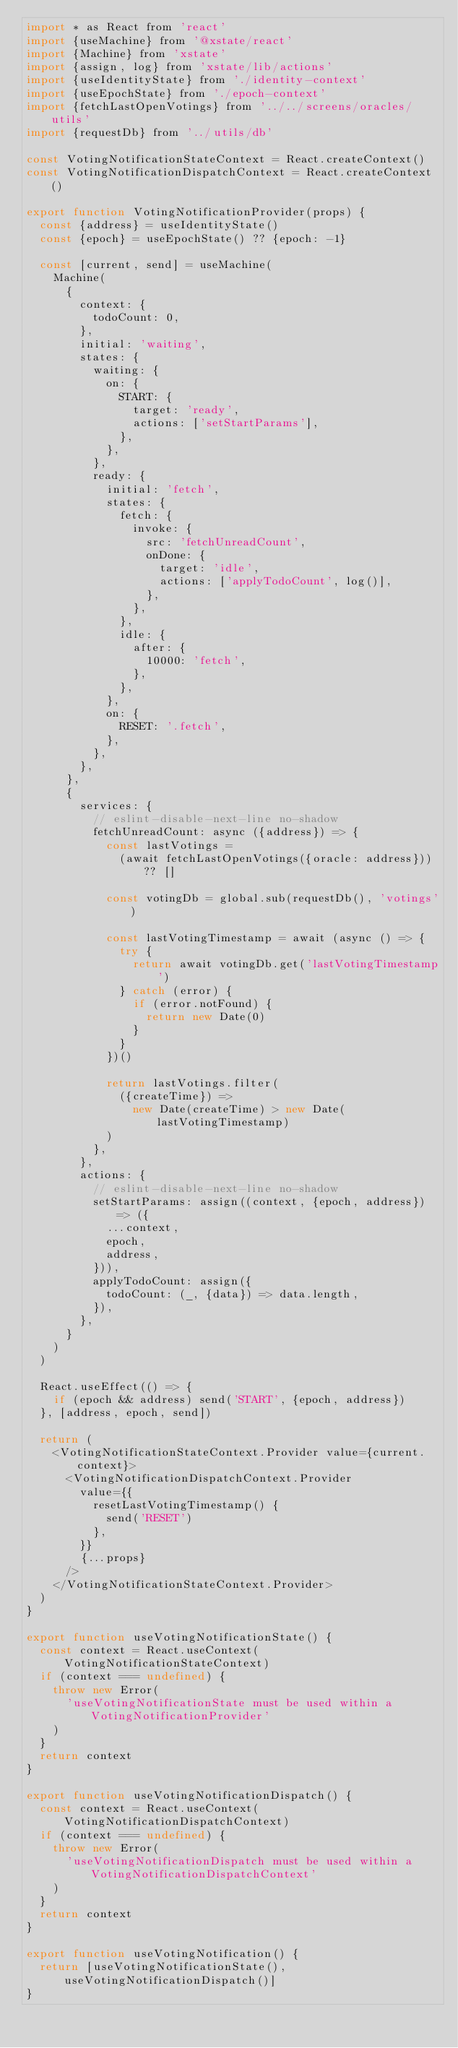<code> <loc_0><loc_0><loc_500><loc_500><_JavaScript_>import * as React from 'react'
import {useMachine} from '@xstate/react'
import {Machine} from 'xstate'
import {assign, log} from 'xstate/lib/actions'
import {useIdentityState} from './identity-context'
import {useEpochState} from './epoch-context'
import {fetchLastOpenVotings} from '../../screens/oracles/utils'
import {requestDb} from '../utils/db'

const VotingNotificationStateContext = React.createContext()
const VotingNotificationDispatchContext = React.createContext()

export function VotingNotificationProvider(props) {
  const {address} = useIdentityState()
  const {epoch} = useEpochState() ?? {epoch: -1}

  const [current, send] = useMachine(
    Machine(
      {
        context: {
          todoCount: 0,
        },
        initial: 'waiting',
        states: {
          waiting: {
            on: {
              START: {
                target: 'ready',
                actions: ['setStartParams'],
              },
            },
          },
          ready: {
            initial: 'fetch',
            states: {
              fetch: {
                invoke: {
                  src: 'fetchUnreadCount',
                  onDone: {
                    target: 'idle',
                    actions: ['applyTodoCount', log()],
                  },
                },
              },
              idle: {
                after: {
                  10000: 'fetch',
                },
              },
            },
            on: {
              RESET: '.fetch',
            },
          },
        },
      },
      {
        services: {
          // eslint-disable-next-line no-shadow
          fetchUnreadCount: async ({address}) => {
            const lastVotings =
              (await fetchLastOpenVotings({oracle: address})) ?? []

            const votingDb = global.sub(requestDb(), 'votings')

            const lastVotingTimestamp = await (async () => {
              try {
                return await votingDb.get('lastVotingTimestamp')
              } catch (error) {
                if (error.notFound) {
                  return new Date(0)
                }
              }
            })()

            return lastVotings.filter(
              ({createTime}) =>
                new Date(createTime) > new Date(lastVotingTimestamp)
            )
          },
        },
        actions: {
          // eslint-disable-next-line no-shadow
          setStartParams: assign((context, {epoch, address}) => ({
            ...context,
            epoch,
            address,
          })),
          applyTodoCount: assign({
            todoCount: (_, {data}) => data.length,
          }),
        },
      }
    )
  )

  React.useEffect(() => {
    if (epoch && address) send('START', {epoch, address})
  }, [address, epoch, send])

  return (
    <VotingNotificationStateContext.Provider value={current.context}>
      <VotingNotificationDispatchContext.Provider
        value={{
          resetLastVotingTimestamp() {
            send('RESET')
          },
        }}
        {...props}
      />
    </VotingNotificationStateContext.Provider>
  )
}

export function useVotingNotificationState() {
  const context = React.useContext(VotingNotificationStateContext)
  if (context === undefined) {
    throw new Error(
      'useVotingNotificationState must be used within a VotingNotificationProvider'
    )
  }
  return context
}

export function useVotingNotificationDispatch() {
  const context = React.useContext(VotingNotificationDispatchContext)
  if (context === undefined) {
    throw new Error(
      'useVotingNotificationDispatch must be used within a VotingNotificationDispatchContext'
    )
  }
  return context
}

export function useVotingNotification() {
  return [useVotingNotificationState(), useVotingNotificationDispatch()]
}
</code> 